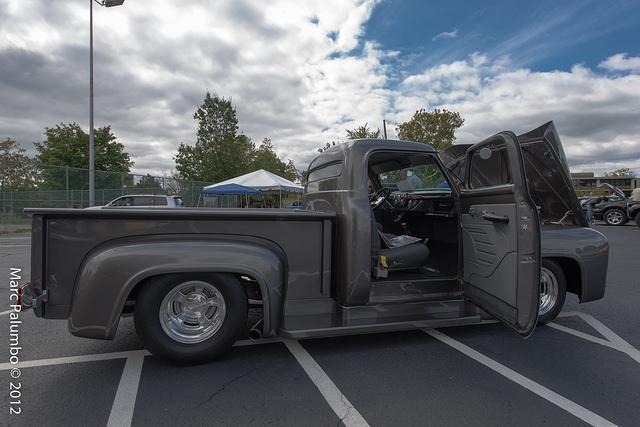How many people are between the two orange buses in the image?
Give a very brief answer. 0. 